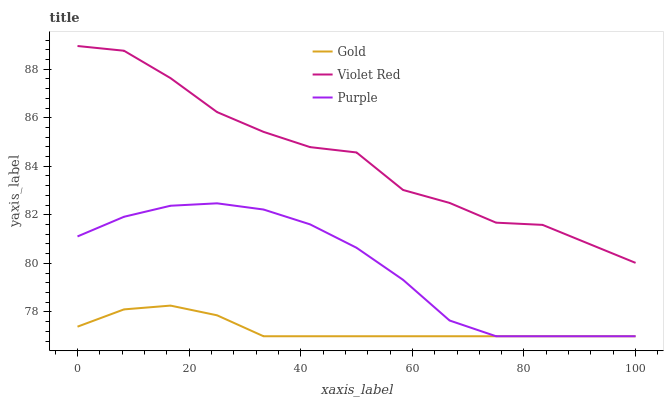Does Gold have the minimum area under the curve?
Answer yes or no. Yes. Does Violet Red have the maximum area under the curve?
Answer yes or no. Yes. Does Violet Red have the minimum area under the curve?
Answer yes or no. No. Does Gold have the maximum area under the curve?
Answer yes or no. No. Is Gold the smoothest?
Answer yes or no. Yes. Is Violet Red the roughest?
Answer yes or no. Yes. Is Violet Red the smoothest?
Answer yes or no. No. Is Gold the roughest?
Answer yes or no. No. Does Purple have the lowest value?
Answer yes or no. Yes. Does Violet Red have the lowest value?
Answer yes or no. No. Does Violet Red have the highest value?
Answer yes or no. Yes. Does Gold have the highest value?
Answer yes or no. No. Is Purple less than Violet Red?
Answer yes or no. Yes. Is Violet Red greater than Gold?
Answer yes or no. Yes. Does Gold intersect Purple?
Answer yes or no. Yes. Is Gold less than Purple?
Answer yes or no. No. Is Gold greater than Purple?
Answer yes or no. No. Does Purple intersect Violet Red?
Answer yes or no. No. 